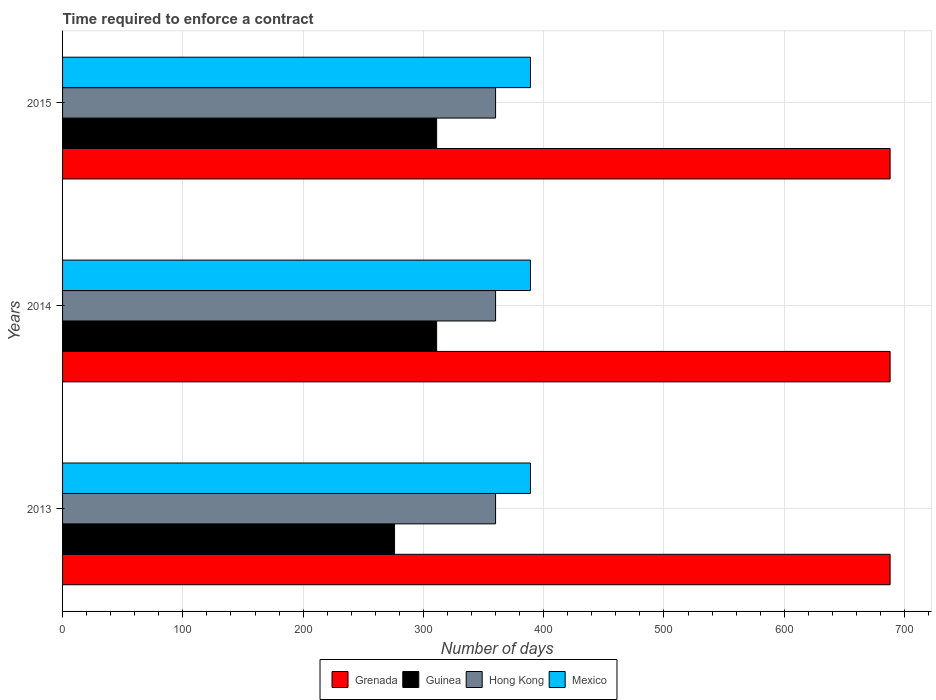How many bars are there on the 2nd tick from the top?
Your response must be concise. 4. How many bars are there on the 3rd tick from the bottom?
Make the answer very short. 4. In how many cases, is the number of bars for a given year not equal to the number of legend labels?
Your response must be concise. 0. What is the number of days required to enforce a contract in Guinea in 2015?
Offer a very short reply. 311. Across all years, what is the maximum number of days required to enforce a contract in Grenada?
Provide a succinct answer. 688. Across all years, what is the minimum number of days required to enforce a contract in Mexico?
Your answer should be compact. 389. In which year was the number of days required to enforce a contract in Mexico minimum?
Make the answer very short. 2013. What is the total number of days required to enforce a contract in Mexico in the graph?
Provide a short and direct response. 1167. What is the difference between the number of days required to enforce a contract in Hong Kong in 2013 and that in 2014?
Keep it short and to the point. 0. What is the difference between the number of days required to enforce a contract in Guinea in 2014 and the number of days required to enforce a contract in Grenada in 2013?
Ensure brevity in your answer.  -377. What is the average number of days required to enforce a contract in Guinea per year?
Ensure brevity in your answer.  299.33. In the year 2014, what is the difference between the number of days required to enforce a contract in Guinea and number of days required to enforce a contract in Mexico?
Provide a short and direct response. -78. What is the ratio of the number of days required to enforce a contract in Grenada in 2013 to that in 2014?
Give a very brief answer. 1. Is the difference between the number of days required to enforce a contract in Guinea in 2014 and 2015 greater than the difference between the number of days required to enforce a contract in Mexico in 2014 and 2015?
Keep it short and to the point. No. What is the difference between the highest and the second highest number of days required to enforce a contract in Grenada?
Provide a short and direct response. 0. What does the 2nd bar from the top in 2013 represents?
Make the answer very short. Hong Kong. What does the 2nd bar from the bottom in 2015 represents?
Provide a succinct answer. Guinea. Does the graph contain any zero values?
Make the answer very short. No. Where does the legend appear in the graph?
Make the answer very short. Bottom center. How are the legend labels stacked?
Your response must be concise. Horizontal. What is the title of the graph?
Make the answer very short. Time required to enforce a contract. Does "Least developed countries" appear as one of the legend labels in the graph?
Offer a very short reply. No. What is the label or title of the X-axis?
Your response must be concise. Number of days. What is the Number of days in Grenada in 2013?
Keep it short and to the point. 688. What is the Number of days in Guinea in 2013?
Your response must be concise. 276. What is the Number of days in Hong Kong in 2013?
Keep it short and to the point. 360. What is the Number of days in Mexico in 2013?
Ensure brevity in your answer.  389. What is the Number of days in Grenada in 2014?
Your response must be concise. 688. What is the Number of days of Guinea in 2014?
Keep it short and to the point. 311. What is the Number of days of Hong Kong in 2014?
Offer a terse response. 360. What is the Number of days of Mexico in 2014?
Your answer should be compact. 389. What is the Number of days in Grenada in 2015?
Your answer should be compact. 688. What is the Number of days in Guinea in 2015?
Provide a short and direct response. 311. What is the Number of days in Hong Kong in 2015?
Keep it short and to the point. 360. What is the Number of days in Mexico in 2015?
Provide a short and direct response. 389. Across all years, what is the maximum Number of days of Grenada?
Give a very brief answer. 688. Across all years, what is the maximum Number of days in Guinea?
Provide a short and direct response. 311. Across all years, what is the maximum Number of days in Hong Kong?
Provide a succinct answer. 360. Across all years, what is the maximum Number of days in Mexico?
Offer a terse response. 389. Across all years, what is the minimum Number of days of Grenada?
Offer a terse response. 688. Across all years, what is the minimum Number of days in Guinea?
Make the answer very short. 276. Across all years, what is the minimum Number of days of Hong Kong?
Ensure brevity in your answer.  360. Across all years, what is the minimum Number of days of Mexico?
Give a very brief answer. 389. What is the total Number of days in Grenada in the graph?
Your answer should be very brief. 2064. What is the total Number of days of Guinea in the graph?
Your answer should be very brief. 898. What is the total Number of days in Hong Kong in the graph?
Your answer should be compact. 1080. What is the total Number of days in Mexico in the graph?
Your answer should be very brief. 1167. What is the difference between the Number of days in Grenada in 2013 and that in 2014?
Provide a short and direct response. 0. What is the difference between the Number of days of Guinea in 2013 and that in 2014?
Provide a succinct answer. -35. What is the difference between the Number of days of Grenada in 2013 and that in 2015?
Keep it short and to the point. 0. What is the difference between the Number of days of Guinea in 2013 and that in 2015?
Make the answer very short. -35. What is the difference between the Number of days of Hong Kong in 2013 and that in 2015?
Ensure brevity in your answer.  0. What is the difference between the Number of days of Mexico in 2013 and that in 2015?
Provide a succinct answer. 0. What is the difference between the Number of days in Grenada in 2014 and that in 2015?
Provide a succinct answer. 0. What is the difference between the Number of days of Guinea in 2014 and that in 2015?
Offer a very short reply. 0. What is the difference between the Number of days of Hong Kong in 2014 and that in 2015?
Make the answer very short. 0. What is the difference between the Number of days in Mexico in 2014 and that in 2015?
Your answer should be very brief. 0. What is the difference between the Number of days in Grenada in 2013 and the Number of days in Guinea in 2014?
Your response must be concise. 377. What is the difference between the Number of days of Grenada in 2013 and the Number of days of Hong Kong in 2014?
Your answer should be very brief. 328. What is the difference between the Number of days in Grenada in 2013 and the Number of days in Mexico in 2014?
Make the answer very short. 299. What is the difference between the Number of days of Guinea in 2013 and the Number of days of Hong Kong in 2014?
Your answer should be very brief. -84. What is the difference between the Number of days in Guinea in 2013 and the Number of days in Mexico in 2014?
Provide a succinct answer. -113. What is the difference between the Number of days in Hong Kong in 2013 and the Number of days in Mexico in 2014?
Ensure brevity in your answer.  -29. What is the difference between the Number of days of Grenada in 2013 and the Number of days of Guinea in 2015?
Make the answer very short. 377. What is the difference between the Number of days of Grenada in 2013 and the Number of days of Hong Kong in 2015?
Offer a very short reply. 328. What is the difference between the Number of days in Grenada in 2013 and the Number of days in Mexico in 2015?
Make the answer very short. 299. What is the difference between the Number of days in Guinea in 2013 and the Number of days in Hong Kong in 2015?
Provide a succinct answer. -84. What is the difference between the Number of days in Guinea in 2013 and the Number of days in Mexico in 2015?
Keep it short and to the point. -113. What is the difference between the Number of days of Hong Kong in 2013 and the Number of days of Mexico in 2015?
Provide a succinct answer. -29. What is the difference between the Number of days in Grenada in 2014 and the Number of days in Guinea in 2015?
Your answer should be very brief. 377. What is the difference between the Number of days of Grenada in 2014 and the Number of days of Hong Kong in 2015?
Your answer should be compact. 328. What is the difference between the Number of days of Grenada in 2014 and the Number of days of Mexico in 2015?
Provide a succinct answer. 299. What is the difference between the Number of days of Guinea in 2014 and the Number of days of Hong Kong in 2015?
Give a very brief answer. -49. What is the difference between the Number of days of Guinea in 2014 and the Number of days of Mexico in 2015?
Give a very brief answer. -78. What is the average Number of days in Grenada per year?
Your answer should be compact. 688. What is the average Number of days in Guinea per year?
Ensure brevity in your answer.  299.33. What is the average Number of days in Hong Kong per year?
Your answer should be compact. 360. What is the average Number of days in Mexico per year?
Offer a terse response. 389. In the year 2013, what is the difference between the Number of days in Grenada and Number of days in Guinea?
Offer a terse response. 412. In the year 2013, what is the difference between the Number of days in Grenada and Number of days in Hong Kong?
Offer a terse response. 328. In the year 2013, what is the difference between the Number of days in Grenada and Number of days in Mexico?
Provide a short and direct response. 299. In the year 2013, what is the difference between the Number of days in Guinea and Number of days in Hong Kong?
Your response must be concise. -84. In the year 2013, what is the difference between the Number of days of Guinea and Number of days of Mexico?
Offer a terse response. -113. In the year 2014, what is the difference between the Number of days of Grenada and Number of days of Guinea?
Ensure brevity in your answer.  377. In the year 2014, what is the difference between the Number of days of Grenada and Number of days of Hong Kong?
Your answer should be very brief. 328. In the year 2014, what is the difference between the Number of days of Grenada and Number of days of Mexico?
Your response must be concise. 299. In the year 2014, what is the difference between the Number of days in Guinea and Number of days in Hong Kong?
Keep it short and to the point. -49. In the year 2014, what is the difference between the Number of days of Guinea and Number of days of Mexico?
Your response must be concise. -78. In the year 2014, what is the difference between the Number of days in Hong Kong and Number of days in Mexico?
Provide a short and direct response. -29. In the year 2015, what is the difference between the Number of days of Grenada and Number of days of Guinea?
Offer a terse response. 377. In the year 2015, what is the difference between the Number of days of Grenada and Number of days of Hong Kong?
Provide a short and direct response. 328. In the year 2015, what is the difference between the Number of days of Grenada and Number of days of Mexico?
Your answer should be very brief. 299. In the year 2015, what is the difference between the Number of days of Guinea and Number of days of Hong Kong?
Offer a terse response. -49. In the year 2015, what is the difference between the Number of days in Guinea and Number of days in Mexico?
Your answer should be very brief. -78. In the year 2015, what is the difference between the Number of days of Hong Kong and Number of days of Mexico?
Offer a terse response. -29. What is the ratio of the Number of days in Guinea in 2013 to that in 2014?
Your answer should be compact. 0.89. What is the ratio of the Number of days of Grenada in 2013 to that in 2015?
Your answer should be very brief. 1. What is the ratio of the Number of days in Guinea in 2013 to that in 2015?
Keep it short and to the point. 0.89. What is the ratio of the Number of days of Grenada in 2014 to that in 2015?
Offer a very short reply. 1. What is the ratio of the Number of days of Guinea in 2014 to that in 2015?
Your response must be concise. 1. What is the difference between the highest and the second highest Number of days of Grenada?
Give a very brief answer. 0. What is the difference between the highest and the second highest Number of days of Hong Kong?
Your response must be concise. 0. What is the difference between the highest and the lowest Number of days of Mexico?
Keep it short and to the point. 0. 